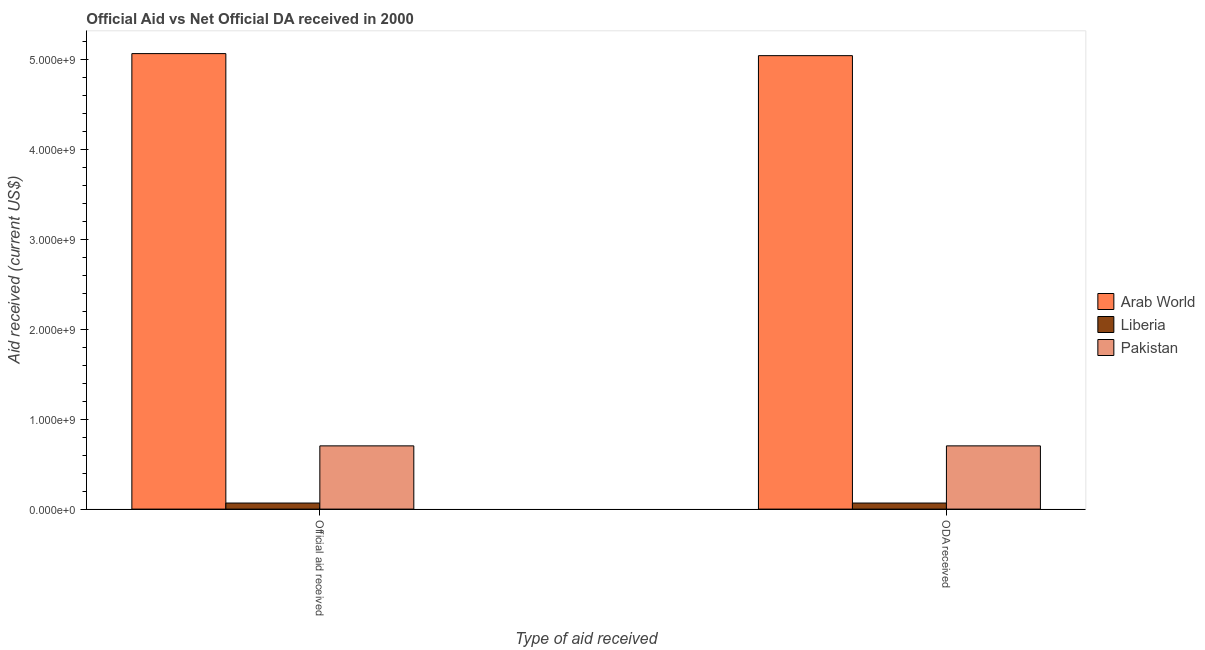Are the number of bars per tick equal to the number of legend labels?
Offer a very short reply. Yes. Are the number of bars on each tick of the X-axis equal?
Provide a short and direct response. Yes. How many bars are there on the 1st tick from the left?
Give a very brief answer. 3. What is the label of the 1st group of bars from the left?
Offer a very short reply. Official aid received. What is the oda received in Pakistan?
Offer a very short reply. 7.03e+08. Across all countries, what is the maximum official aid received?
Your response must be concise. 5.06e+09. Across all countries, what is the minimum official aid received?
Ensure brevity in your answer.  6.74e+07. In which country was the oda received maximum?
Your answer should be very brief. Arab World. In which country was the oda received minimum?
Make the answer very short. Liberia. What is the total official aid received in the graph?
Give a very brief answer. 5.83e+09. What is the difference between the oda received in Pakistan and that in Arab World?
Keep it short and to the point. -4.34e+09. What is the difference between the official aid received in Pakistan and the oda received in Liberia?
Keep it short and to the point. 6.35e+08. What is the average oda received per country?
Offer a very short reply. 1.94e+09. What is the difference between the official aid received and oda received in Arab World?
Your answer should be very brief. 2.28e+07. What is the ratio of the oda received in Liberia to that in Arab World?
Offer a terse response. 0.01. In how many countries, is the oda received greater than the average oda received taken over all countries?
Offer a very short reply. 1. What does the 3rd bar from the left in ODA received represents?
Provide a short and direct response. Pakistan. What does the 1st bar from the right in Official aid received represents?
Keep it short and to the point. Pakistan. How many countries are there in the graph?
Keep it short and to the point. 3. Are the values on the major ticks of Y-axis written in scientific E-notation?
Provide a succinct answer. Yes. Does the graph contain grids?
Your answer should be very brief. No. How many legend labels are there?
Your answer should be very brief. 3. How are the legend labels stacked?
Offer a terse response. Vertical. What is the title of the graph?
Provide a short and direct response. Official Aid vs Net Official DA received in 2000 . Does "New Caledonia" appear as one of the legend labels in the graph?
Provide a succinct answer. No. What is the label or title of the X-axis?
Your answer should be compact. Type of aid received. What is the label or title of the Y-axis?
Ensure brevity in your answer.  Aid received (current US$). What is the Aid received (current US$) of Arab World in Official aid received?
Provide a short and direct response. 5.06e+09. What is the Aid received (current US$) of Liberia in Official aid received?
Give a very brief answer. 6.74e+07. What is the Aid received (current US$) of Pakistan in Official aid received?
Keep it short and to the point. 7.03e+08. What is the Aid received (current US$) in Arab World in ODA received?
Your response must be concise. 5.04e+09. What is the Aid received (current US$) of Liberia in ODA received?
Your response must be concise. 6.74e+07. What is the Aid received (current US$) in Pakistan in ODA received?
Give a very brief answer. 7.03e+08. Across all Type of aid received, what is the maximum Aid received (current US$) of Arab World?
Your answer should be very brief. 5.06e+09. Across all Type of aid received, what is the maximum Aid received (current US$) of Liberia?
Ensure brevity in your answer.  6.74e+07. Across all Type of aid received, what is the maximum Aid received (current US$) in Pakistan?
Offer a very short reply. 7.03e+08. Across all Type of aid received, what is the minimum Aid received (current US$) in Arab World?
Make the answer very short. 5.04e+09. Across all Type of aid received, what is the minimum Aid received (current US$) of Liberia?
Give a very brief answer. 6.74e+07. Across all Type of aid received, what is the minimum Aid received (current US$) in Pakistan?
Offer a terse response. 7.03e+08. What is the total Aid received (current US$) in Arab World in the graph?
Provide a succinct answer. 1.01e+1. What is the total Aid received (current US$) of Liberia in the graph?
Your answer should be compact. 1.35e+08. What is the total Aid received (current US$) of Pakistan in the graph?
Offer a very short reply. 1.41e+09. What is the difference between the Aid received (current US$) in Arab World in Official aid received and that in ODA received?
Give a very brief answer. 2.28e+07. What is the difference between the Aid received (current US$) in Liberia in Official aid received and that in ODA received?
Keep it short and to the point. 0. What is the difference between the Aid received (current US$) in Arab World in Official aid received and the Aid received (current US$) in Liberia in ODA received?
Provide a succinct answer. 4.99e+09. What is the difference between the Aid received (current US$) of Arab World in Official aid received and the Aid received (current US$) of Pakistan in ODA received?
Provide a short and direct response. 4.36e+09. What is the difference between the Aid received (current US$) in Liberia in Official aid received and the Aid received (current US$) in Pakistan in ODA received?
Ensure brevity in your answer.  -6.35e+08. What is the average Aid received (current US$) of Arab World per Type of aid received?
Offer a terse response. 5.05e+09. What is the average Aid received (current US$) in Liberia per Type of aid received?
Provide a short and direct response. 6.74e+07. What is the average Aid received (current US$) in Pakistan per Type of aid received?
Give a very brief answer. 7.03e+08. What is the difference between the Aid received (current US$) in Arab World and Aid received (current US$) in Liberia in Official aid received?
Make the answer very short. 4.99e+09. What is the difference between the Aid received (current US$) in Arab World and Aid received (current US$) in Pakistan in Official aid received?
Offer a terse response. 4.36e+09. What is the difference between the Aid received (current US$) in Liberia and Aid received (current US$) in Pakistan in Official aid received?
Make the answer very short. -6.35e+08. What is the difference between the Aid received (current US$) of Arab World and Aid received (current US$) of Liberia in ODA received?
Make the answer very short. 4.97e+09. What is the difference between the Aid received (current US$) in Arab World and Aid received (current US$) in Pakistan in ODA received?
Keep it short and to the point. 4.34e+09. What is the difference between the Aid received (current US$) of Liberia and Aid received (current US$) of Pakistan in ODA received?
Give a very brief answer. -6.35e+08. What is the ratio of the Aid received (current US$) in Arab World in Official aid received to that in ODA received?
Provide a succinct answer. 1. What is the ratio of the Aid received (current US$) of Liberia in Official aid received to that in ODA received?
Offer a very short reply. 1. What is the ratio of the Aid received (current US$) of Pakistan in Official aid received to that in ODA received?
Keep it short and to the point. 1. What is the difference between the highest and the second highest Aid received (current US$) in Arab World?
Give a very brief answer. 2.28e+07. What is the difference between the highest and the lowest Aid received (current US$) of Arab World?
Offer a very short reply. 2.28e+07. 